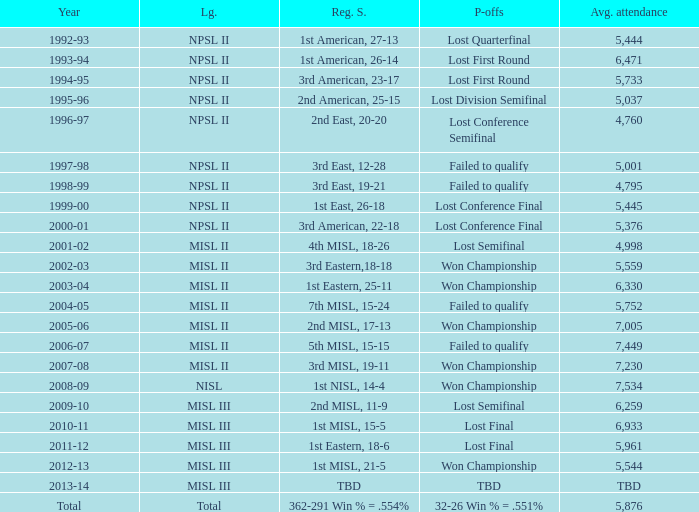In 2010-11, what was the League name? MISL III. 